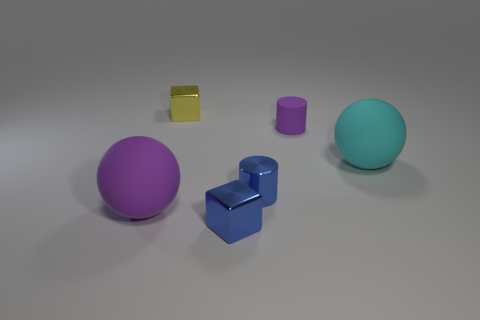How many objects are tiny metal cylinders or purple matte balls?
Keep it short and to the point. 2. Does the purple object in front of the purple matte cylinder have the same material as the tiny blue cylinder?
Keep it short and to the point. No. How many things are either things that are in front of the big purple ball or spheres?
Your answer should be very brief. 3. There is a cylinder that is made of the same material as the small yellow cube; what is its color?
Ensure brevity in your answer.  Blue. Are there any cyan balls of the same size as the purple matte cylinder?
Ensure brevity in your answer.  No. There is a cube that is in front of the small purple matte cylinder; is its color the same as the small metal cylinder?
Your response must be concise. Yes. The rubber object that is behind the metal cylinder and left of the cyan ball is what color?
Ensure brevity in your answer.  Purple. What is the shape of the purple object that is the same size as the cyan rubber object?
Your answer should be very brief. Sphere. Is there a tiny metal thing of the same shape as the large cyan thing?
Keep it short and to the point. No. Do the blue cylinder to the right of the yellow metallic cube and the cyan rubber object have the same size?
Make the answer very short. No. 